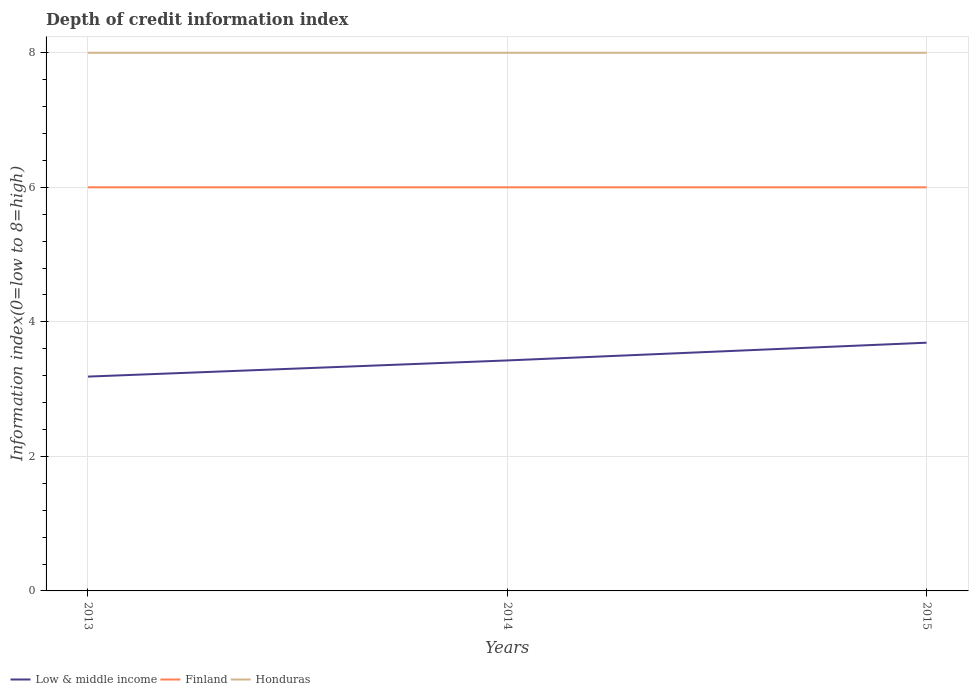Does the line corresponding to Low & middle income intersect with the line corresponding to Finland?
Ensure brevity in your answer.  No. Is the number of lines equal to the number of legend labels?
Offer a very short reply. Yes. Across all years, what is the maximum information index in Finland?
Provide a succinct answer. 6. In which year was the information index in Finland maximum?
Your answer should be very brief. 2013. What is the total information index in Finland in the graph?
Provide a succinct answer. 0. What is the difference between the highest and the second highest information index in Honduras?
Offer a terse response. 0. Is the information index in Finland strictly greater than the information index in Honduras over the years?
Your answer should be very brief. Yes. How many years are there in the graph?
Offer a very short reply. 3. What is the difference between two consecutive major ticks on the Y-axis?
Provide a short and direct response. 2. Does the graph contain any zero values?
Your response must be concise. No. Does the graph contain grids?
Offer a very short reply. Yes. What is the title of the graph?
Your answer should be very brief. Depth of credit information index. Does "Middle East & North Africa (developing only)" appear as one of the legend labels in the graph?
Your answer should be compact. No. What is the label or title of the X-axis?
Give a very brief answer. Years. What is the label or title of the Y-axis?
Your response must be concise. Information index(0=low to 8=high). What is the Information index(0=low to 8=high) of Low & middle income in 2013?
Provide a succinct answer. 3.19. What is the Information index(0=low to 8=high) in Low & middle income in 2014?
Offer a terse response. 3.43. What is the Information index(0=low to 8=high) of Low & middle income in 2015?
Give a very brief answer. 3.69. What is the Information index(0=low to 8=high) of Finland in 2015?
Your answer should be compact. 6. What is the Information index(0=low to 8=high) of Honduras in 2015?
Offer a very short reply. 8. Across all years, what is the maximum Information index(0=low to 8=high) in Low & middle income?
Provide a short and direct response. 3.69. Across all years, what is the maximum Information index(0=low to 8=high) of Finland?
Offer a very short reply. 6. Across all years, what is the maximum Information index(0=low to 8=high) of Honduras?
Provide a short and direct response. 8. Across all years, what is the minimum Information index(0=low to 8=high) of Low & middle income?
Provide a succinct answer. 3.19. What is the total Information index(0=low to 8=high) in Low & middle income in the graph?
Keep it short and to the point. 10.3. What is the total Information index(0=low to 8=high) of Finland in the graph?
Provide a short and direct response. 18. What is the total Information index(0=low to 8=high) of Honduras in the graph?
Keep it short and to the point. 24. What is the difference between the Information index(0=low to 8=high) in Low & middle income in 2013 and that in 2014?
Keep it short and to the point. -0.24. What is the difference between the Information index(0=low to 8=high) of Finland in 2013 and that in 2014?
Provide a succinct answer. 0. What is the difference between the Information index(0=low to 8=high) of Low & middle income in 2013 and that in 2015?
Offer a terse response. -0.5. What is the difference between the Information index(0=low to 8=high) in Finland in 2013 and that in 2015?
Make the answer very short. 0. What is the difference between the Information index(0=low to 8=high) in Low & middle income in 2014 and that in 2015?
Keep it short and to the point. -0.26. What is the difference between the Information index(0=low to 8=high) in Finland in 2014 and that in 2015?
Provide a succinct answer. 0. What is the difference between the Information index(0=low to 8=high) in Low & middle income in 2013 and the Information index(0=low to 8=high) in Finland in 2014?
Provide a short and direct response. -2.81. What is the difference between the Information index(0=low to 8=high) in Low & middle income in 2013 and the Information index(0=low to 8=high) in Honduras in 2014?
Ensure brevity in your answer.  -4.81. What is the difference between the Information index(0=low to 8=high) in Low & middle income in 2013 and the Information index(0=low to 8=high) in Finland in 2015?
Your answer should be compact. -2.81. What is the difference between the Information index(0=low to 8=high) in Low & middle income in 2013 and the Information index(0=low to 8=high) in Honduras in 2015?
Your answer should be compact. -4.81. What is the difference between the Information index(0=low to 8=high) of Low & middle income in 2014 and the Information index(0=low to 8=high) of Finland in 2015?
Provide a succinct answer. -2.57. What is the difference between the Information index(0=low to 8=high) of Low & middle income in 2014 and the Information index(0=low to 8=high) of Honduras in 2015?
Offer a very short reply. -4.57. What is the average Information index(0=low to 8=high) of Low & middle income per year?
Your answer should be very brief. 3.43. What is the average Information index(0=low to 8=high) in Honduras per year?
Your answer should be very brief. 8. In the year 2013, what is the difference between the Information index(0=low to 8=high) of Low & middle income and Information index(0=low to 8=high) of Finland?
Make the answer very short. -2.81. In the year 2013, what is the difference between the Information index(0=low to 8=high) in Low & middle income and Information index(0=low to 8=high) in Honduras?
Offer a terse response. -4.81. In the year 2014, what is the difference between the Information index(0=low to 8=high) of Low & middle income and Information index(0=low to 8=high) of Finland?
Make the answer very short. -2.57. In the year 2014, what is the difference between the Information index(0=low to 8=high) of Low & middle income and Information index(0=low to 8=high) of Honduras?
Offer a terse response. -4.57. In the year 2014, what is the difference between the Information index(0=low to 8=high) of Finland and Information index(0=low to 8=high) of Honduras?
Provide a short and direct response. -2. In the year 2015, what is the difference between the Information index(0=low to 8=high) of Low & middle income and Information index(0=low to 8=high) of Finland?
Your answer should be compact. -2.31. In the year 2015, what is the difference between the Information index(0=low to 8=high) of Low & middle income and Information index(0=low to 8=high) of Honduras?
Your answer should be compact. -4.31. In the year 2015, what is the difference between the Information index(0=low to 8=high) of Finland and Information index(0=low to 8=high) of Honduras?
Provide a short and direct response. -2. What is the ratio of the Information index(0=low to 8=high) of Low & middle income in 2013 to that in 2014?
Make the answer very short. 0.93. What is the ratio of the Information index(0=low to 8=high) of Finland in 2013 to that in 2014?
Your answer should be very brief. 1. What is the ratio of the Information index(0=low to 8=high) of Low & middle income in 2013 to that in 2015?
Keep it short and to the point. 0.86. What is the ratio of the Information index(0=low to 8=high) of Finland in 2013 to that in 2015?
Your answer should be very brief. 1. What is the ratio of the Information index(0=low to 8=high) in Low & middle income in 2014 to that in 2015?
Your answer should be compact. 0.93. What is the ratio of the Information index(0=low to 8=high) of Finland in 2014 to that in 2015?
Your response must be concise. 1. What is the difference between the highest and the second highest Information index(0=low to 8=high) in Low & middle income?
Keep it short and to the point. 0.26. What is the difference between the highest and the second highest Information index(0=low to 8=high) in Honduras?
Give a very brief answer. 0. What is the difference between the highest and the lowest Information index(0=low to 8=high) of Low & middle income?
Offer a very short reply. 0.5. 